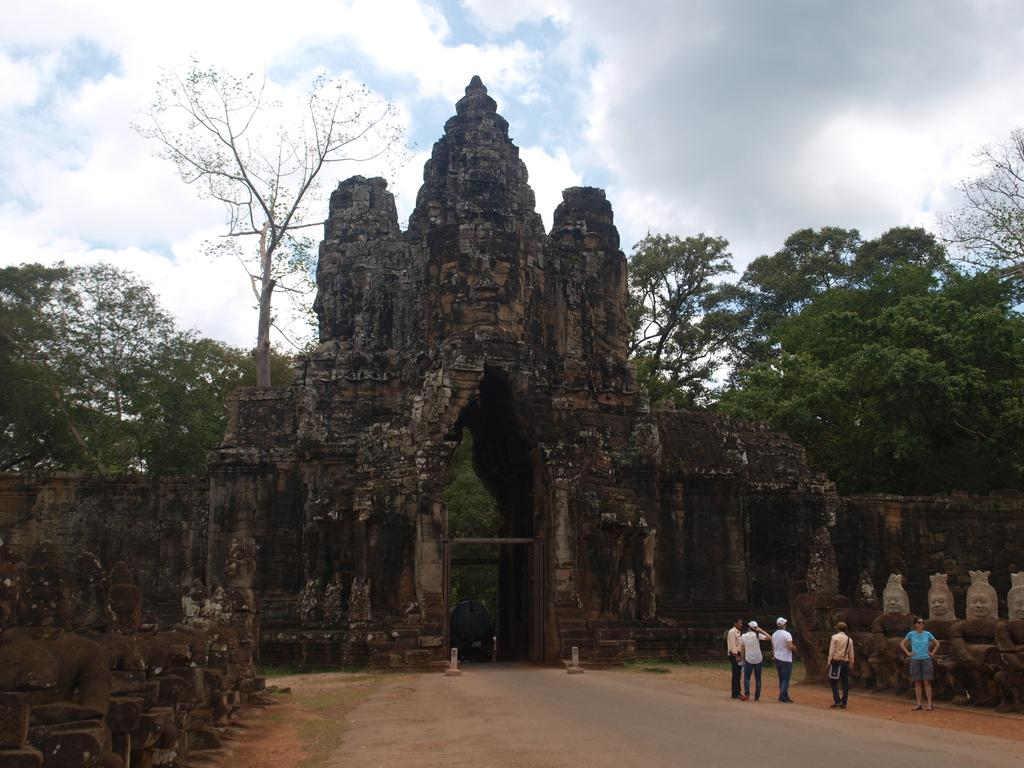What is the main subject of the image? The main subject of the image is people standing in front of a fort. What can be seen in the background of the image? There are trees around the area. What type of celery can be seen growing near the fort in the image? There is no celery present in the image. How many arches can be seen on the fort in the image? The image does not provide enough detail to determine the number of arches on the fort. 